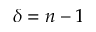<formula> <loc_0><loc_0><loc_500><loc_500>\delta = n - 1</formula> 